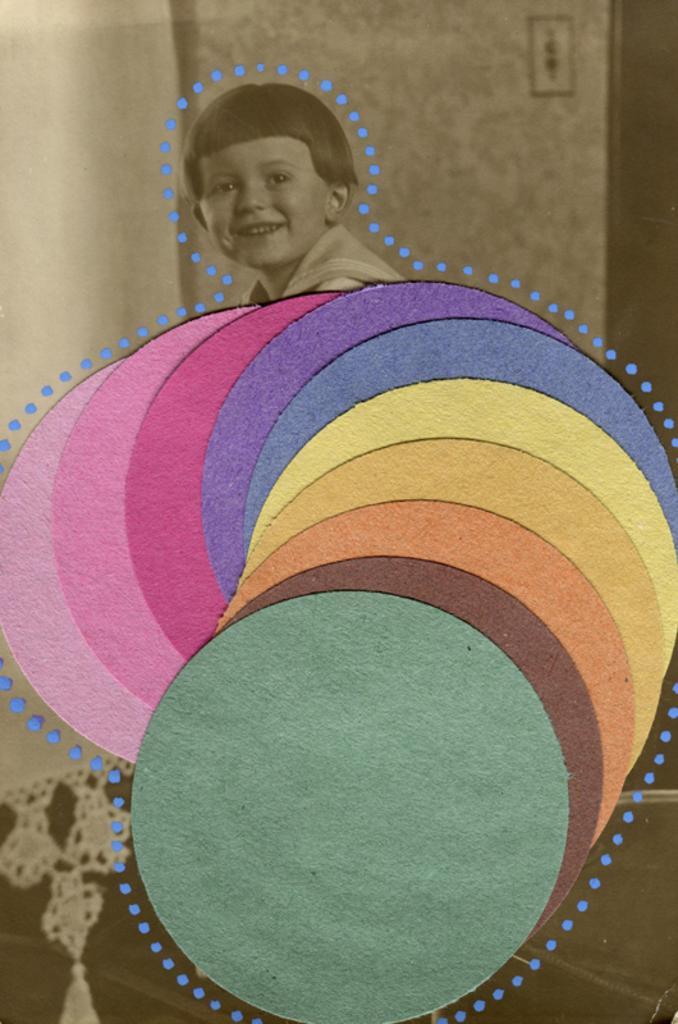Describe this image in one or two sentences. This is an edited image. I can see a kid smiling. In front of the kid, there are different colors. In the background, I can see a curtain and an object attached to the wall. 